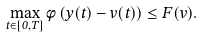<formula> <loc_0><loc_0><loc_500><loc_500>\max _ { t \in [ 0 , T ] } \phi \left ( y ( t ) - v ( t ) \right ) \leq F ( v ) .</formula> 